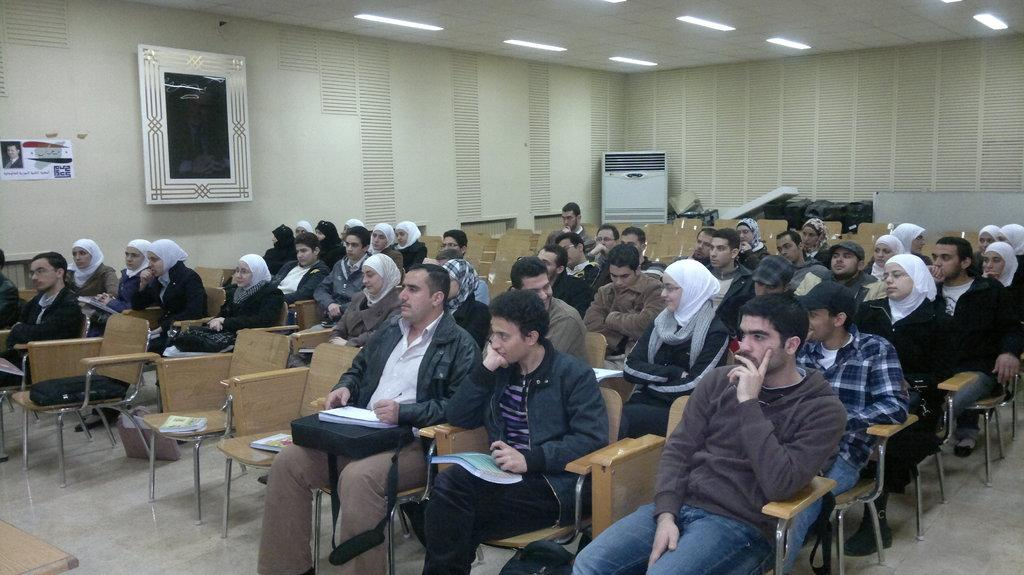How many people are in the image? There are multiple people in the image. What are the people doing in the image? The people are sitting on chairs. Where are the chairs located? The chairs are in a room. What type of hammer is being used by the people in the image? There is no hammer present in the image; the people are sitting on chairs in a room. 